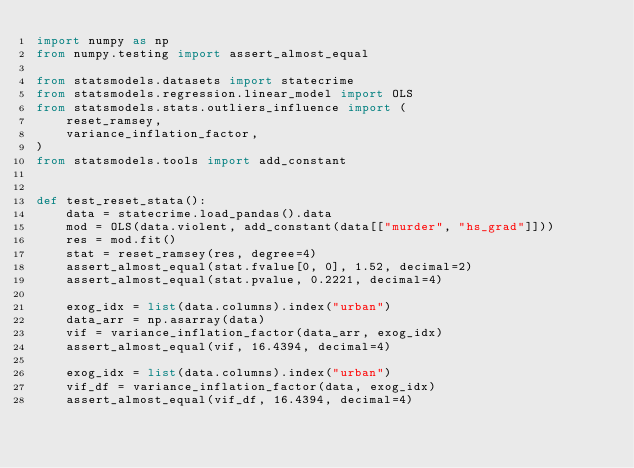Convert code to text. <code><loc_0><loc_0><loc_500><loc_500><_Python_>import numpy as np
from numpy.testing import assert_almost_equal

from statsmodels.datasets import statecrime
from statsmodels.regression.linear_model import OLS
from statsmodels.stats.outliers_influence import (
    reset_ramsey,
    variance_inflation_factor,
)
from statsmodels.tools import add_constant


def test_reset_stata():
    data = statecrime.load_pandas().data
    mod = OLS(data.violent, add_constant(data[["murder", "hs_grad"]]))
    res = mod.fit()
    stat = reset_ramsey(res, degree=4)
    assert_almost_equal(stat.fvalue[0, 0], 1.52, decimal=2)
    assert_almost_equal(stat.pvalue, 0.2221, decimal=4)

    exog_idx = list(data.columns).index("urban")
    data_arr = np.asarray(data)
    vif = variance_inflation_factor(data_arr, exog_idx)
    assert_almost_equal(vif, 16.4394, decimal=4)

    exog_idx = list(data.columns).index("urban")
    vif_df = variance_inflation_factor(data, exog_idx)
    assert_almost_equal(vif_df, 16.4394, decimal=4)
</code> 